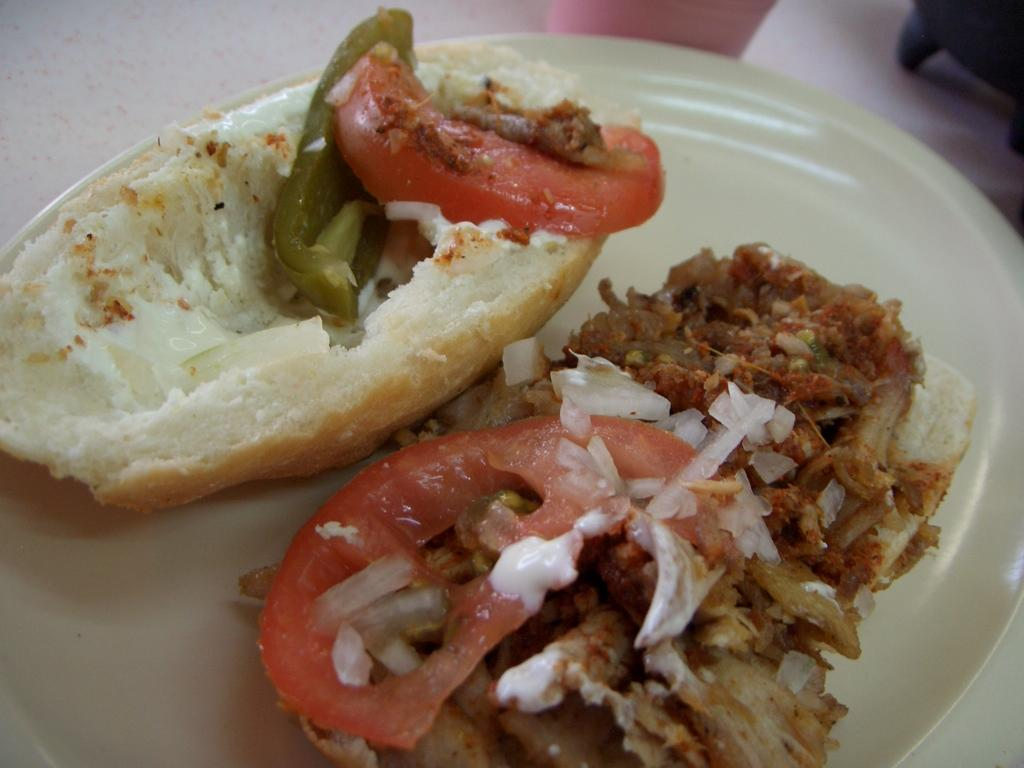What is the main subject of the image? There is a food item in the image. How is the food item presented in the image? The food item is in a white color plate. What page number is the food item located on in the image? The image does not have pages, as it is a single image, so there is no page number for the food item. In which direction is the food item facing in the image? The image does not provide information about the direction the food item is facing, as it only shows the food item in a white color plate. 